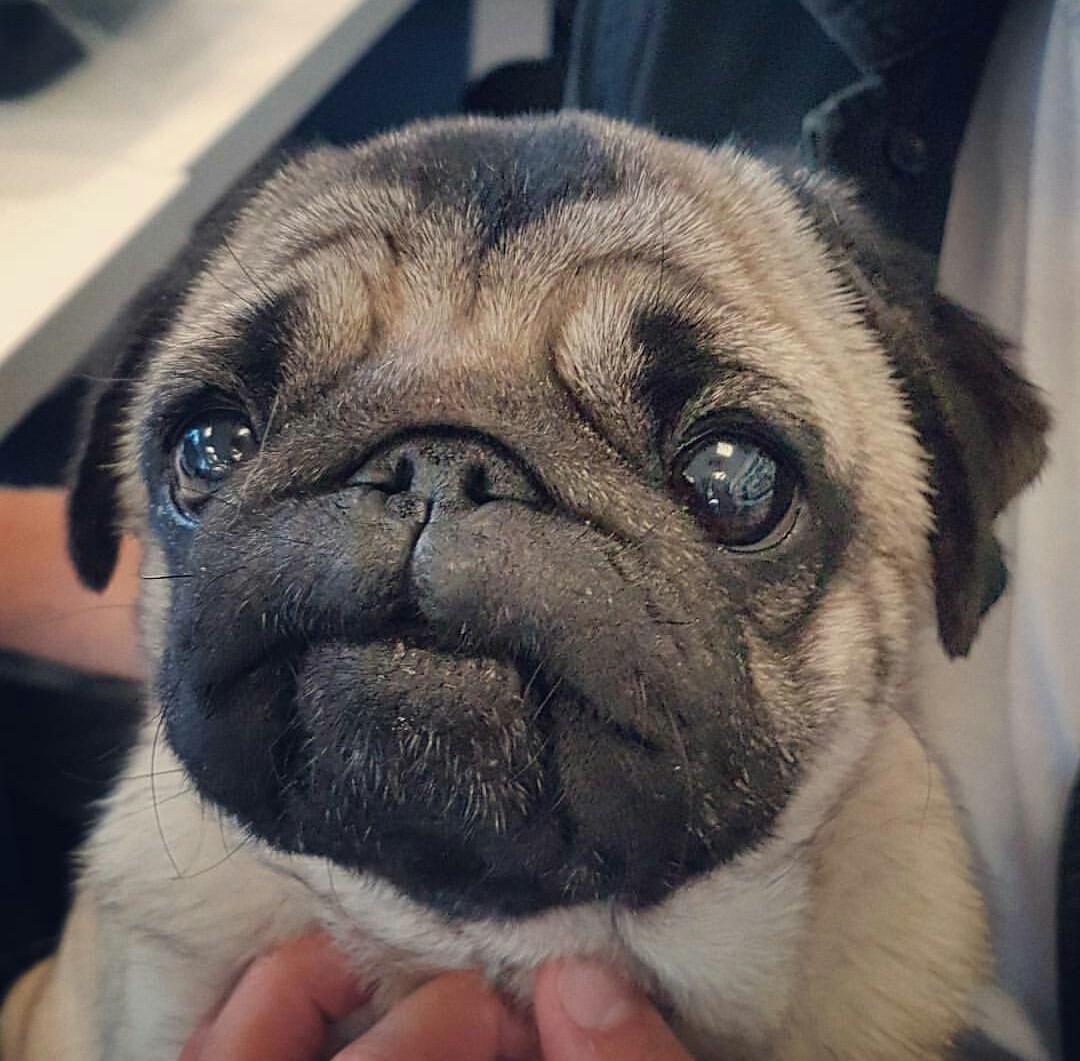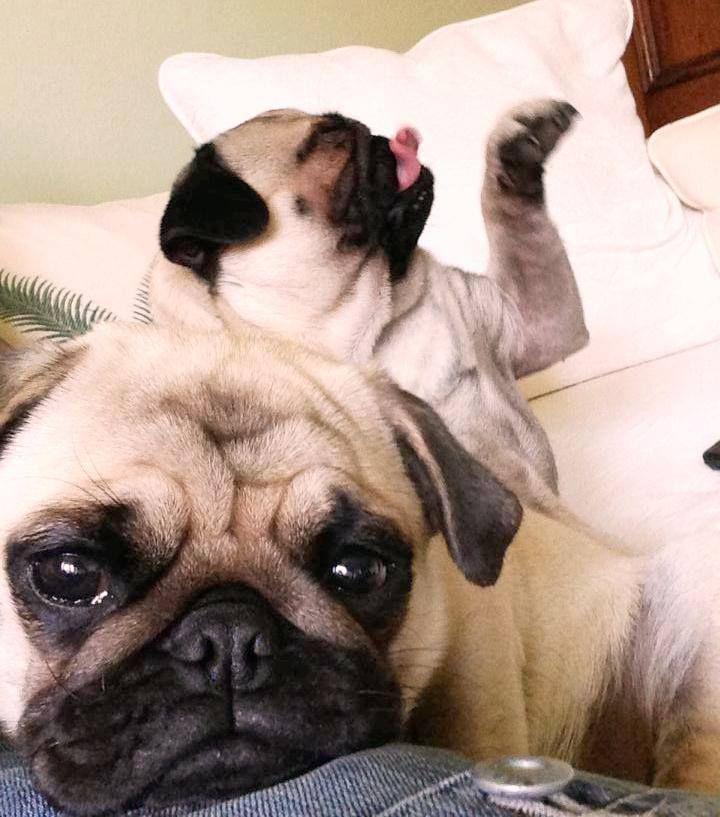The first image is the image on the left, the second image is the image on the right. Evaluate the accuracy of this statement regarding the images: "A human is playing with puppies on the floor". Is it true? Answer yes or no. No. The first image is the image on the left, the second image is the image on the right. Considering the images on both sides, is "A man in a blue and white striped shirt is nuzzling puppies." valid? Answer yes or no. No. 